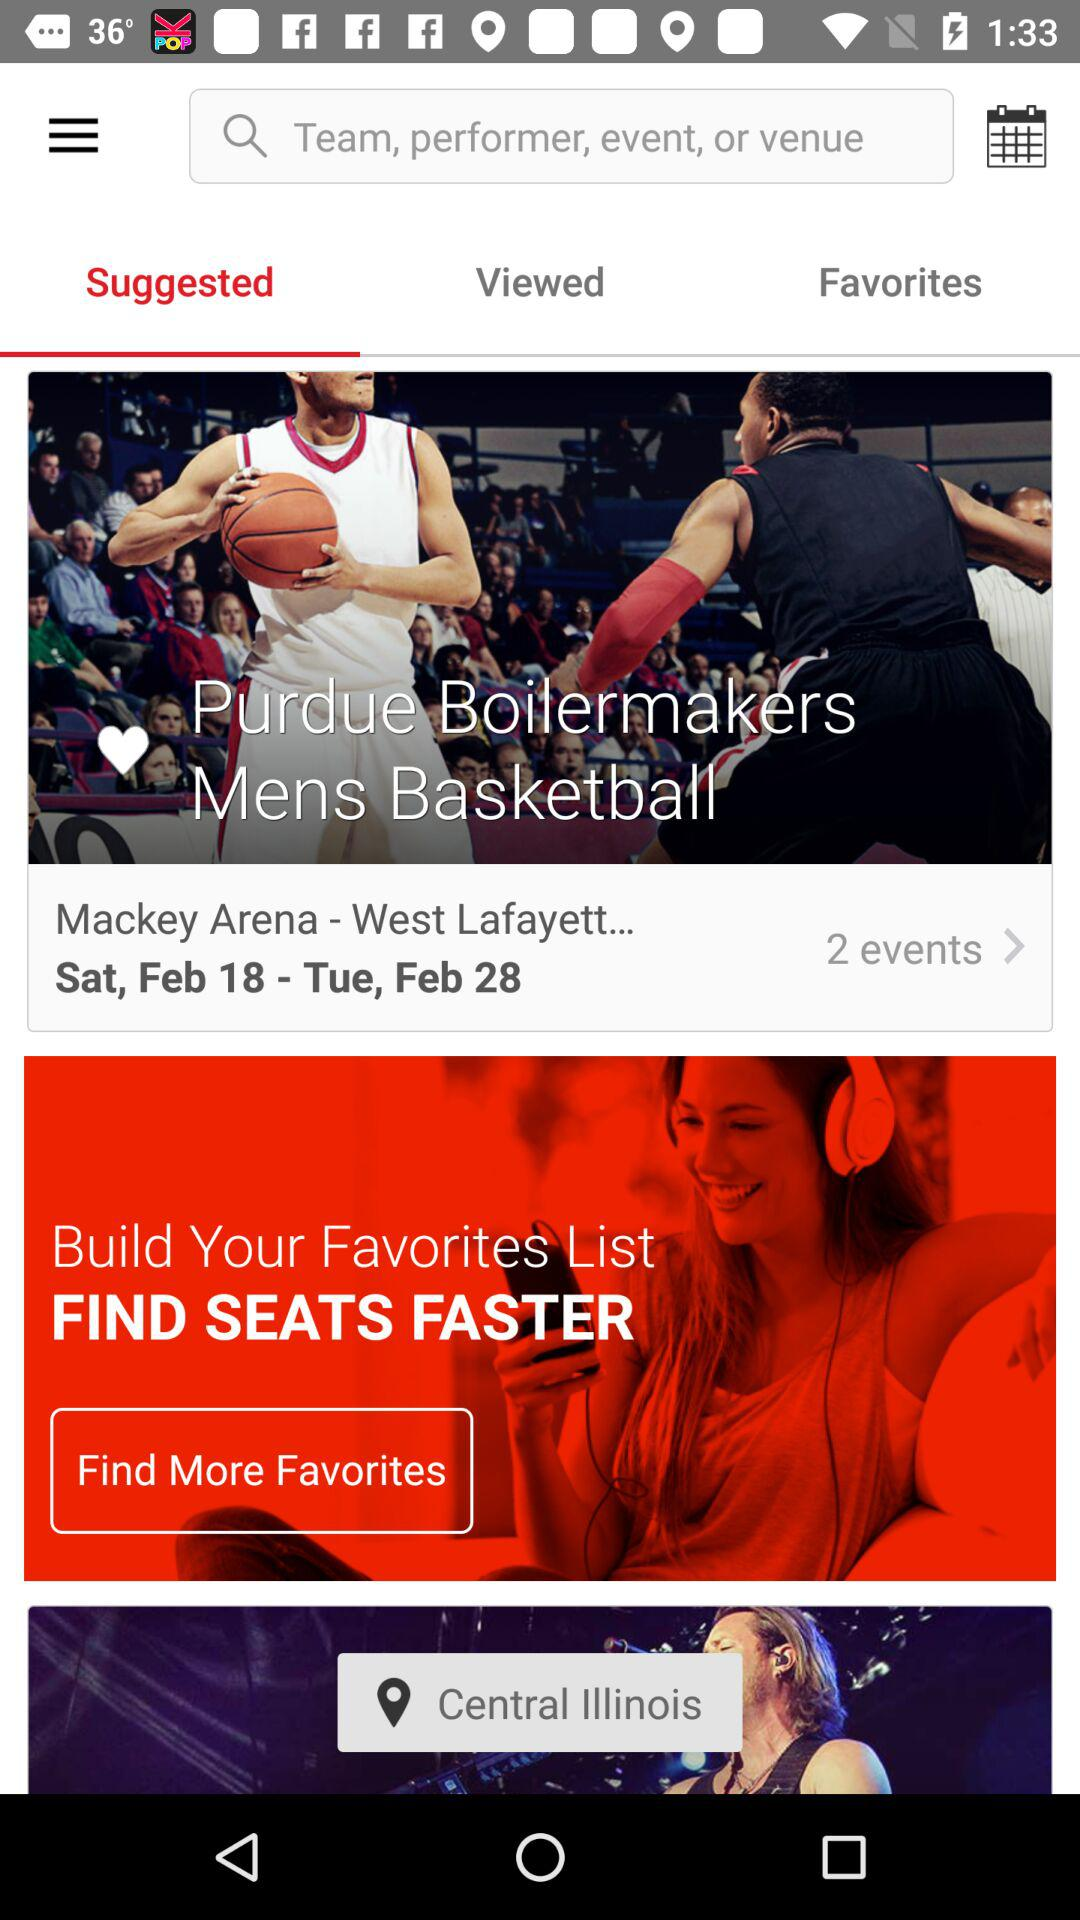What is the selected tab? The selected tab is "Suggested". 